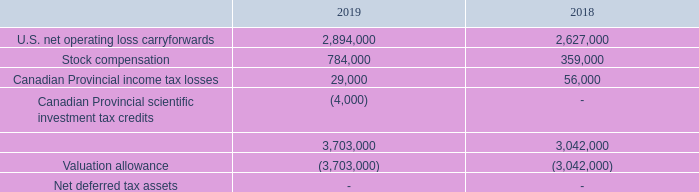The tax effects of temporary differences that give rise to the Company’s deferred tax assets and liabilities are as follows:
As of December 31, 2019 and 2018, the Company had federal net operating loss carryforwards (“NOL”) of approximately $7,161,000 and $6,617,000, respectively. The
losses expire beginning in 2024. The Company has not performed a detailed analysis to determine whether an ownership change under IRC Section 382 has occurred. The effect
of an ownership change would be the imposition of annual limitation on the use of NOL carryforwards attributable to periods before the change Any limitation may result in
expiration of a portion of the NOL before utilization. As of December 31, 2019 and 2018, the Company had state and local net operating loss carryforwards of approximately
$7,153,000 and $6,609,000, respectively, to reduce future state tax liabilities also through 2035.
As of December 31, 2019 and 2018, the Company had Canadian NOL of approximately $1,111,000 and $1,070,000, respectively. The Canadian losses expire in stages
beginning in 2026. As of December 31, 2019 and 2018, the Company also has unclaimed Canadian federal scientific research and development investment tax credits, which are
available to reduce future federal taxes payable of approximately $0 and $0 respectively.
As of December 31, 2019 and 2018, the Company had Canadian NOL of approximately $1,111,000 and $1,070,000, respectively. The Canadian losses expire in stages beginning in 2026. As of December 31, 2019 and 2018, the Company also has unclaimed Canadian federal scientific research and development investment tax credits, which are available to reduce future federal taxes payable of approximately $0 and $0 respectively. As of December 31, 2019 and 2018, the Company had Canadian NOL of approximately $1,111,000 and $1,070,000, respectively. The Canadian losses expire in stages beginning in 2026. As of December 31, 2019 and 2018, the Company also has unclaimed Canadian federal scientific research and development investment tax credits, which are available to reduce future federal taxes payable of approximately $0 and $0 respectively. As of December 31, 2019 and 2018, the Company had Canadian NOL of approximately $1,111,000 and $1,070,000, respectively. The Canadian losses expire in stages beginning in 2026. As of December 31, 2019 and 2018, the Company also has unclaimed Canadian federal scientific research and development investment tax credits, which are available to reduce future federal taxes payable of approximately $0 and $0 respectively.
As a result of losses and uncertainty of future profit, the net deferred tax asset has been fully reserved. The net change in the valuation allowance during the years
ended December 31, 2019 and 2018 was an increase of $661,000 and $457,000, respectively
Foreign earnings are assumed to be permanently reinvested. U.S. Federal income taxes have not been provided on undistributed earnings of our foreign subsidiary.
The Company recognizes interest and penalties related to uncertain tax positions in selling, general and administrative expenses. The Company has not identified any
uncertain tax positions requiring a reserve as of December 31, 2019 and 2018.
The Company is required to file U.S. federal and state income tax returns. These returns are subject to audit by tax authorities beginning with the year ended December 31, 2014.
What is the company's Canadian net operating loss carryforward as of December 31, 2019? $1,111,000. What is the company's Canadian net operating loss carryforward as of December 31, 2018? $1,070,000. When would the Canadian loss start to expire? 2026. What is the percentage change in the Canadian NOL between December 31, 2018 and 2019?
Answer scale should be: percent. (1,111,000 - 1,070,000)/1,070,000 
Answer: 3.83. What is the difference in valuation allowance between 2018 and 2019? 3,703,000 - 3,042,000 
Answer: 661000. What is the change in stock compensation between 2018 and 2019? 784,000 - 359,000 
Answer: 425000. 